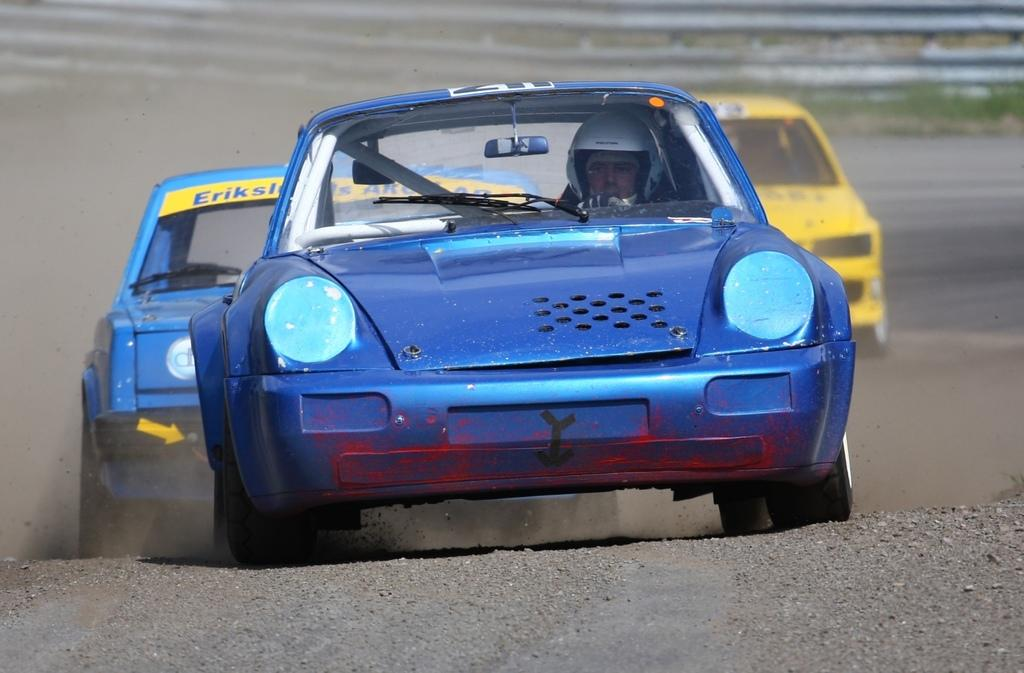What type of vehicles can be seen in the image? There are cars in the image. What is visible in the background of the image? There is a fence in the background of the image. What type of fly can be seen buzzing around the cars in the image? There is no fly present in the image; it only features cars and a fence in the background. 